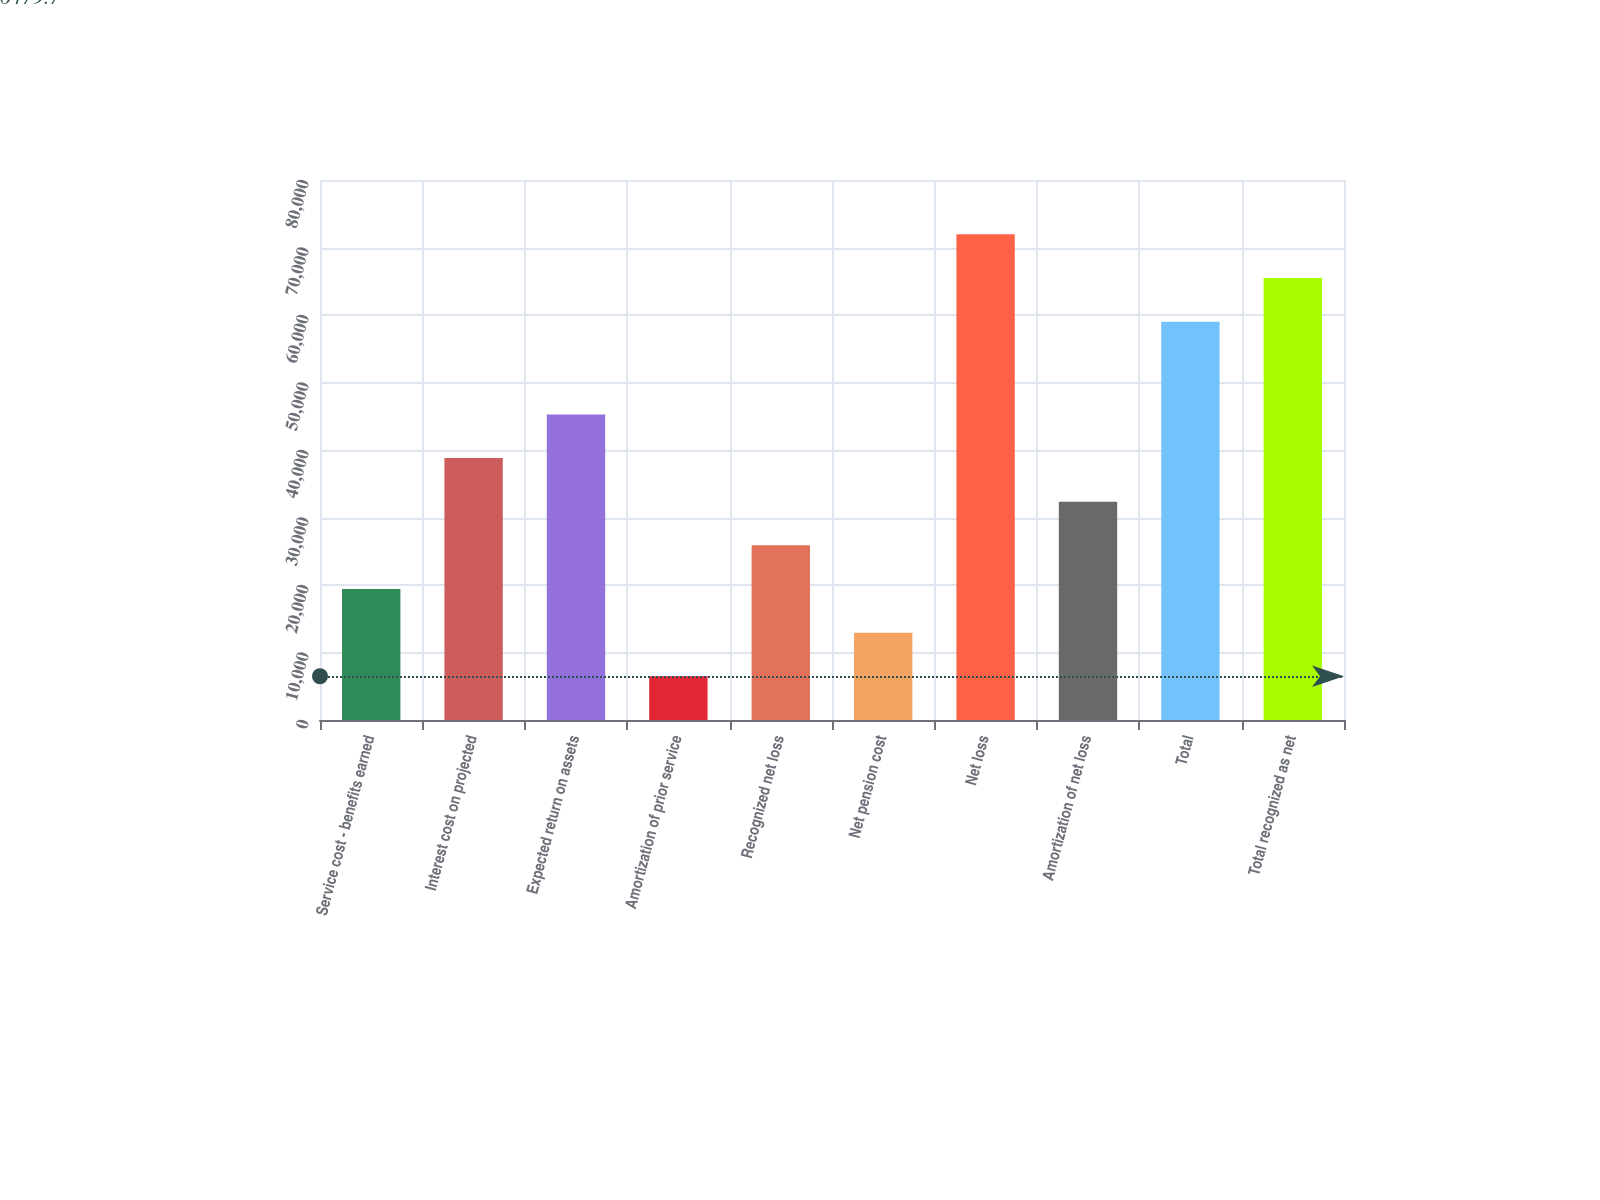<chart> <loc_0><loc_0><loc_500><loc_500><bar_chart><fcel>Service cost - benefits earned<fcel>Interest cost on projected<fcel>Expected return on assets<fcel>Amortization of prior service<fcel>Recognized net loss<fcel>Net pension cost<fcel>Net loss<fcel>Amortization of net loss<fcel>Total<fcel>Total recognized as net<nl><fcel>19409.1<fcel>38803.2<fcel>45267.9<fcel>6479.7<fcel>25873.8<fcel>12944.4<fcel>71947.4<fcel>32338.5<fcel>59018<fcel>65482.7<nl></chart> 